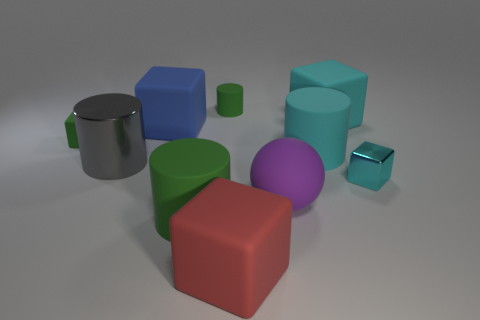Subtract all spheres. How many objects are left? 9 Subtract all blue cubes. How many cubes are left? 4 Subtract all big green rubber cylinders. How many cylinders are left? 3 Subtract 1 blue blocks. How many objects are left? 9 Subtract 1 cylinders. How many cylinders are left? 3 Subtract all purple cubes. Subtract all gray cylinders. How many cubes are left? 5 Subtract all cyan cylinders. How many gray balls are left? 0 Subtract all big blue things. Subtract all cyan shiny things. How many objects are left? 8 Add 1 big objects. How many big objects are left? 8 Add 1 big gray metallic cylinders. How many big gray metallic cylinders exist? 2 